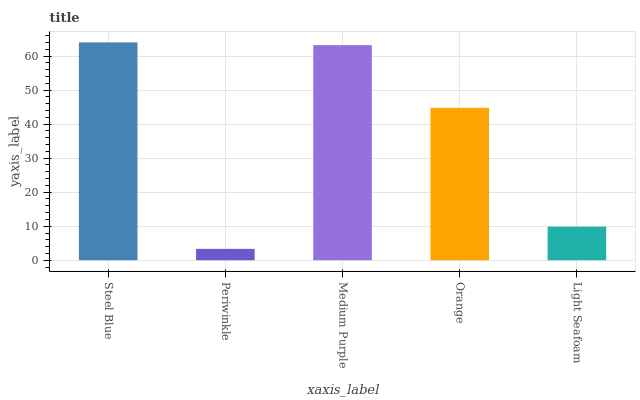Is Periwinkle the minimum?
Answer yes or no. Yes. Is Steel Blue the maximum?
Answer yes or no. Yes. Is Medium Purple the minimum?
Answer yes or no. No. Is Medium Purple the maximum?
Answer yes or no. No. Is Medium Purple greater than Periwinkle?
Answer yes or no. Yes. Is Periwinkle less than Medium Purple?
Answer yes or no. Yes. Is Periwinkle greater than Medium Purple?
Answer yes or no. No. Is Medium Purple less than Periwinkle?
Answer yes or no. No. Is Orange the high median?
Answer yes or no. Yes. Is Orange the low median?
Answer yes or no. Yes. Is Steel Blue the high median?
Answer yes or no. No. Is Light Seafoam the low median?
Answer yes or no. No. 